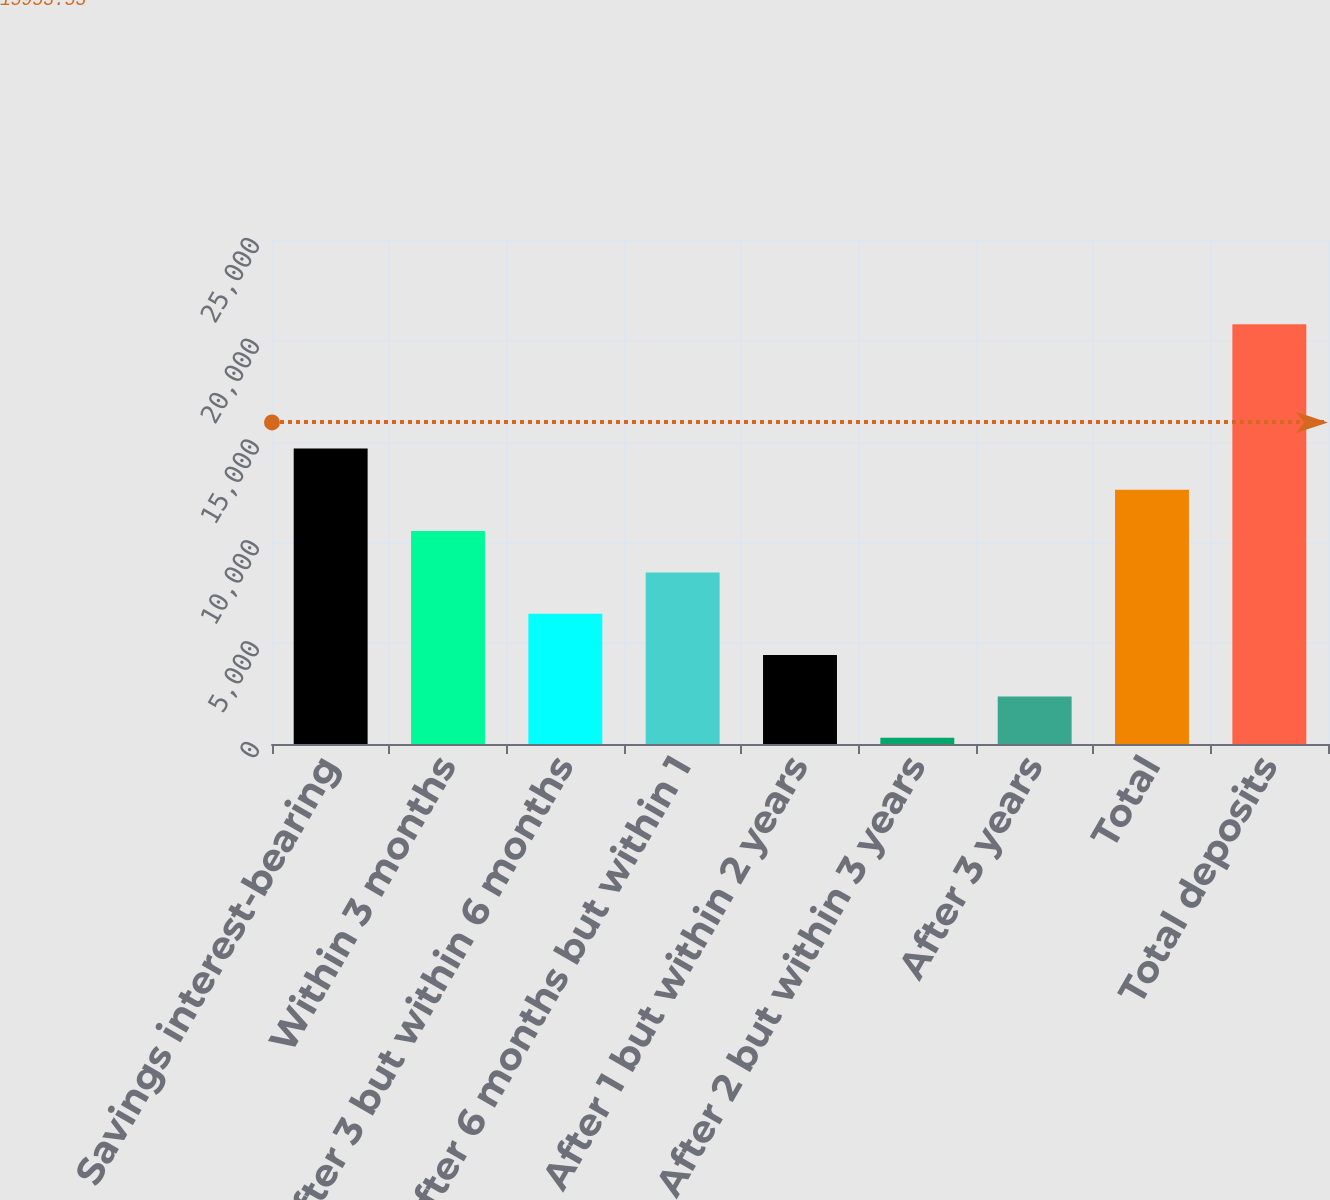<chart> <loc_0><loc_0><loc_500><loc_500><bar_chart><fcel>Savings interest-bearing<fcel>Within 3 months<fcel>After 3 but within 6 months<fcel>After 6 months but within 1<fcel>After 1 but within 2 years<fcel>After 2 but within 3 years<fcel>After 3 years<fcel>Total<fcel>Total deposits<nl><fcel>14663.5<fcel>10561.9<fcel>6460.34<fcel>8511.12<fcel>4409.56<fcel>308<fcel>2358.78<fcel>12612.7<fcel>20815.8<nl></chart> 